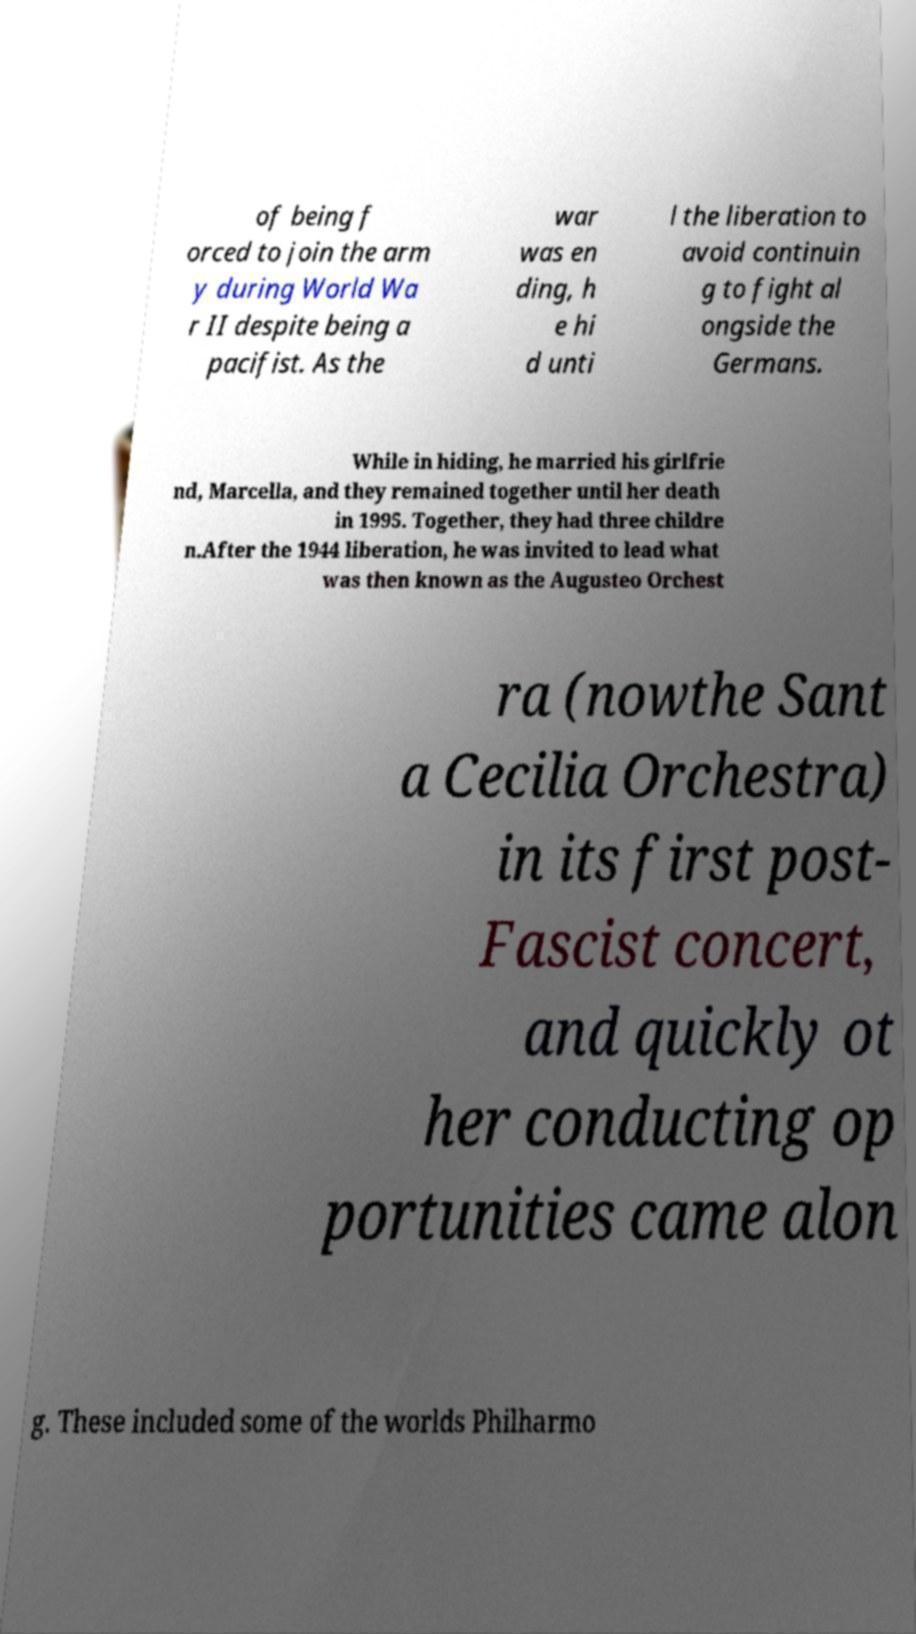There's text embedded in this image that I need extracted. Can you transcribe it verbatim? of being f orced to join the arm y during World Wa r II despite being a pacifist. As the war was en ding, h e hi d unti l the liberation to avoid continuin g to fight al ongside the Germans. While in hiding, he married his girlfrie nd, Marcella, and they remained together until her death in 1995. Together, they had three childre n.After the 1944 liberation, he was invited to lead what was then known as the Augusteo Orchest ra (nowthe Sant a Cecilia Orchestra) in its first post- Fascist concert, and quickly ot her conducting op portunities came alon g. These included some of the worlds Philharmo 